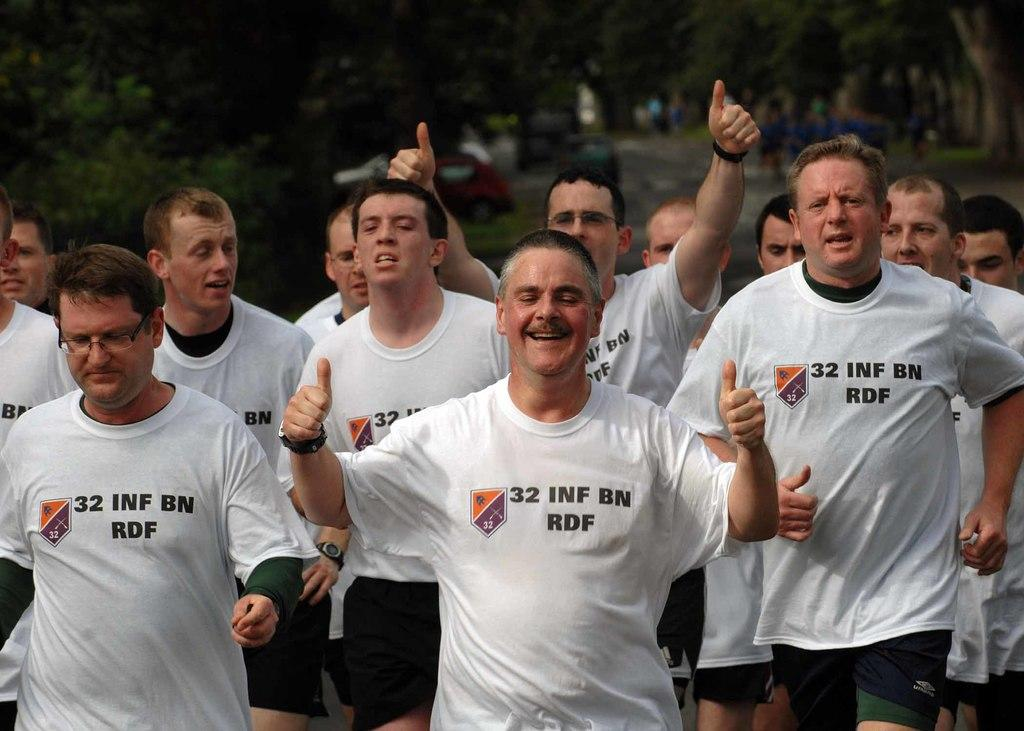What is happening in the image? There is a group of people standing in the image. What can be seen in the background of the image? There are trees and vehicles on the road in the background of the image. What type of bottle is being used for digestion in the image? There is no bottle or reference to digestion present in the image. 